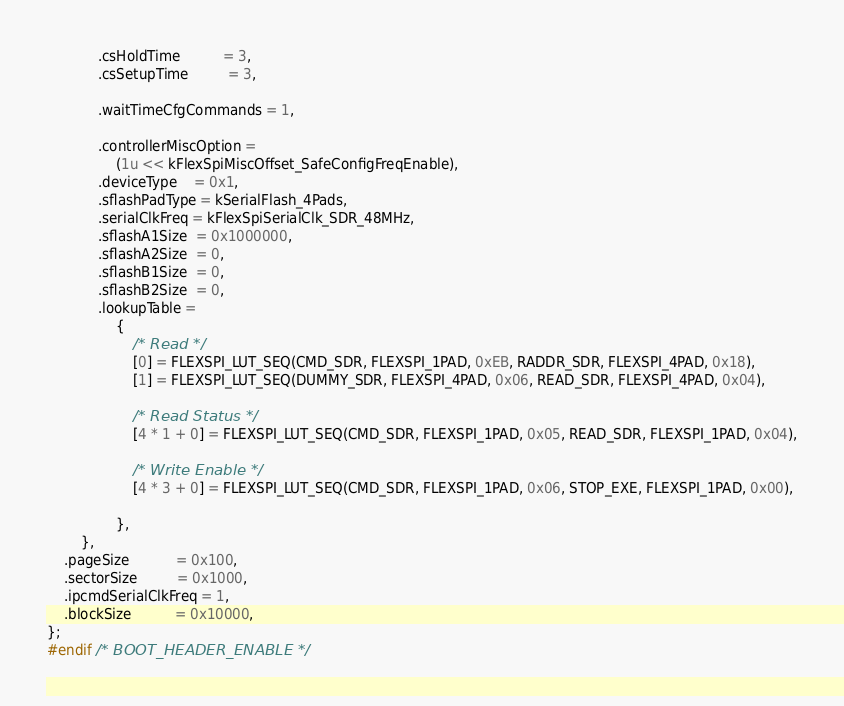<code> <loc_0><loc_0><loc_500><loc_500><_C_>            .csHoldTime          = 3,
            .csSetupTime         = 3,

            .waitTimeCfgCommands = 1,

            .controllerMiscOption =
                (1u << kFlexSpiMiscOffset_SafeConfigFreqEnable),
            .deviceType    = 0x1,
            .sflashPadType = kSerialFlash_4Pads,
            .serialClkFreq = kFlexSpiSerialClk_SDR_48MHz,
            .sflashA1Size  = 0x1000000,
            .sflashA2Size  = 0,
            .sflashB1Size  = 0,
            .sflashB2Size  = 0,
            .lookupTable =
                {
                    /* Read */
                    [0] = FLEXSPI_LUT_SEQ(CMD_SDR, FLEXSPI_1PAD, 0xEB, RADDR_SDR, FLEXSPI_4PAD, 0x18),
                    [1] = FLEXSPI_LUT_SEQ(DUMMY_SDR, FLEXSPI_4PAD, 0x06, READ_SDR, FLEXSPI_4PAD, 0x04),

                    /* Read Status */
                    [4 * 1 + 0] = FLEXSPI_LUT_SEQ(CMD_SDR, FLEXSPI_1PAD, 0x05, READ_SDR, FLEXSPI_1PAD, 0x04),

                    /* Write Enable */
                    [4 * 3 + 0] = FLEXSPI_LUT_SEQ(CMD_SDR, FLEXSPI_1PAD, 0x06, STOP_EXE, FLEXSPI_1PAD, 0x00),

                },
        },
    .pageSize           = 0x100,
    .sectorSize         = 0x1000,
    .ipcmdSerialClkFreq = 1,
    .blockSize          = 0x10000,
};
#endif /* BOOT_HEADER_ENABLE */
</code> 